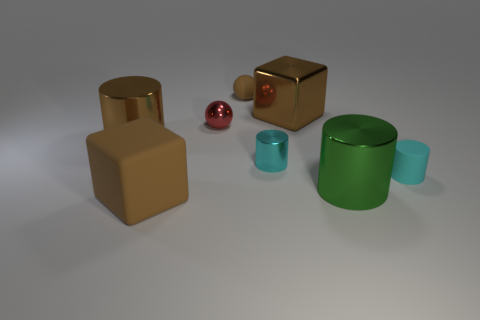What shape is the tiny object that is the same color as the matte cylinder?
Your response must be concise. Cylinder. How many objects are brown metal things that are right of the red thing or large purple rubber balls?
Keep it short and to the point. 1. Is the rubber cylinder the same color as the large rubber object?
Provide a succinct answer. No. What number of other things are there of the same shape as the cyan rubber object?
Provide a succinct answer. 3. How many yellow objects are either blocks or shiny cylinders?
Your answer should be very brief. 0. There is a big cube that is made of the same material as the brown ball; what is its color?
Provide a succinct answer. Brown. Are the tiny cylinder that is to the left of the small cyan matte cylinder and the block that is on the left side of the tiny cyan shiny cylinder made of the same material?
Your answer should be compact. No. The rubber ball that is the same color as the big rubber block is what size?
Keep it short and to the point. Small. There is a small cyan thing that is on the left side of the big green shiny cylinder; what is its material?
Keep it short and to the point. Metal. Do the big brown metallic object that is to the left of the tiny rubber ball and the cyan thing right of the metallic cube have the same shape?
Your answer should be compact. Yes. 